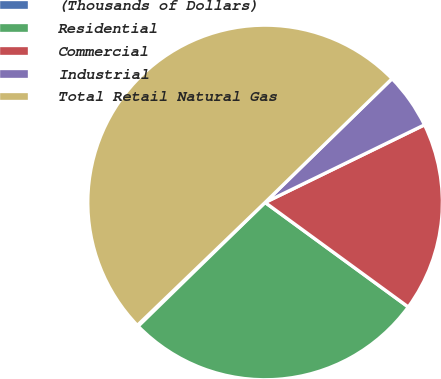Convert chart to OTSL. <chart><loc_0><loc_0><loc_500><loc_500><pie_chart><fcel>(Thousands of Dollars)<fcel>Residential<fcel>Commercial<fcel>Industrial<fcel>Total Retail Natural Gas<nl><fcel>0.11%<fcel>27.66%<fcel>17.25%<fcel>5.09%<fcel>49.89%<nl></chart> 